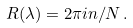<formula> <loc_0><loc_0><loc_500><loc_500>R ( \lambda ) = 2 \pi i n / N \, .</formula> 